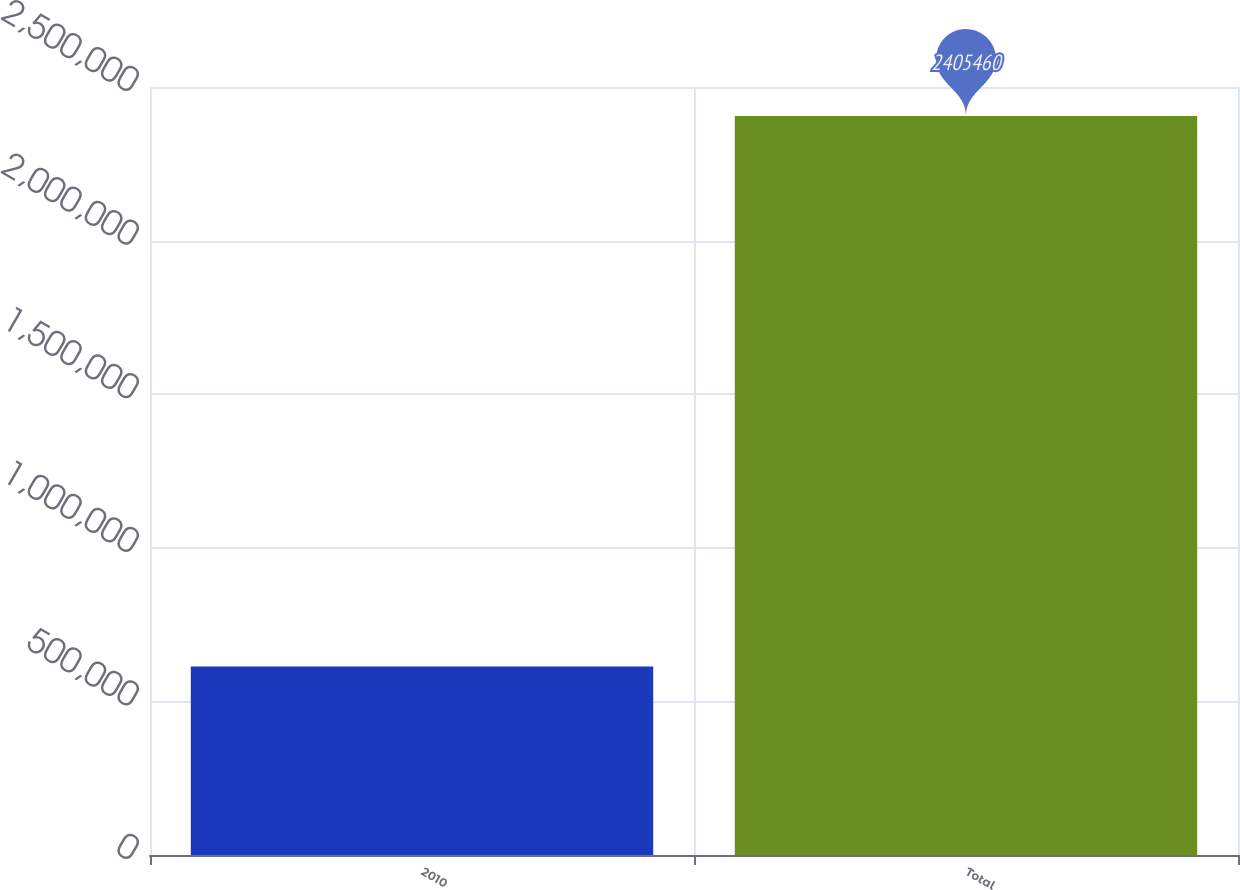Convert chart. <chart><loc_0><loc_0><loc_500><loc_500><bar_chart><fcel>2010<fcel>Total<nl><fcel>613310<fcel>2.40546e+06<nl></chart> 